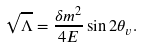Convert formula to latex. <formula><loc_0><loc_0><loc_500><loc_500>\sqrt { \Lambda } = \frac { \delta m ^ { 2 } } { 4 E } \sin { 2 \theta _ { v } } .</formula> 